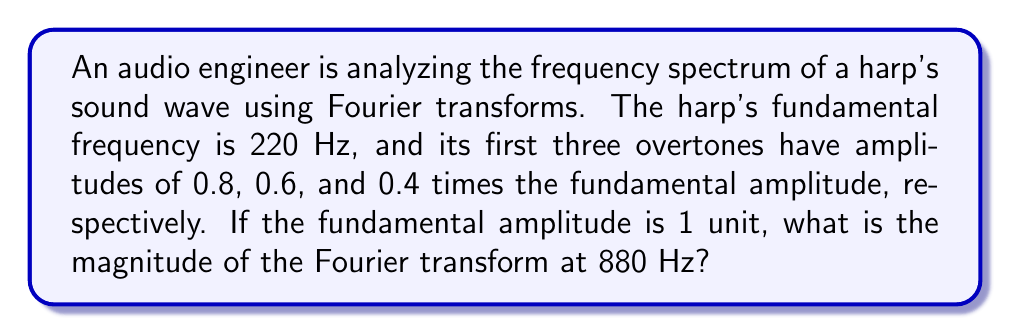What is the answer to this math problem? Let's approach this step-by-step:

1) The fundamental frequency of the harp is 220 Hz. The overtones are integer multiples of this frequency:
   - 1st overtone: 440 Hz
   - 2nd overtone: 660 Hz
   - 3rd overtone: 880 Hz

2) The amplitudes are given as:
   - Fundamental (220 Hz): 1 unit
   - 1st overtone (440 Hz): 0.8 units
   - 2nd overtone (660 Hz): 0.6 units
   - 3rd overtone (880 Hz): 0.4 units

3) The Fourier transform represents the frequency content of the signal. The magnitude of the Fourier transform at a particular frequency corresponds to the amplitude of that frequency component in the original signal.

4) We're asked about the magnitude at 880 Hz, which corresponds to the 3rd overtone.

5) The amplitude of the 3rd overtone is given as 0.4 times the fundamental amplitude.

6) Since the fundamental amplitude is 1 unit, the amplitude of the 3rd overtone is:

   $$ 0.4 \times 1 = 0.4 \text{ units} $$

7) In the Fourier transform, this amplitude directly corresponds to the magnitude at 880 Hz.

Therefore, the magnitude of the Fourier transform at 880 Hz is 0.4 units.
Answer: 0.4 units 